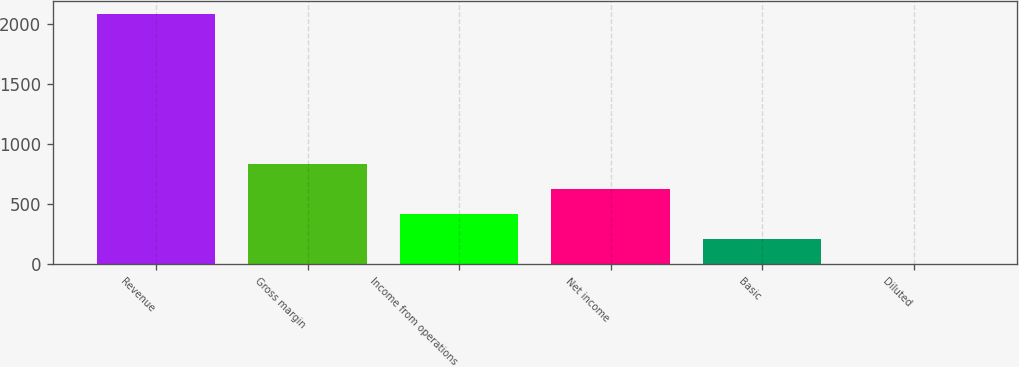Convert chart. <chart><loc_0><loc_0><loc_500><loc_500><bar_chart><fcel>Revenue<fcel>Gross margin<fcel>Income from operations<fcel>Net income<fcel>Basic<fcel>Diluted<nl><fcel>2088<fcel>835.54<fcel>418.04<fcel>626.79<fcel>209.29<fcel>0.54<nl></chart> 